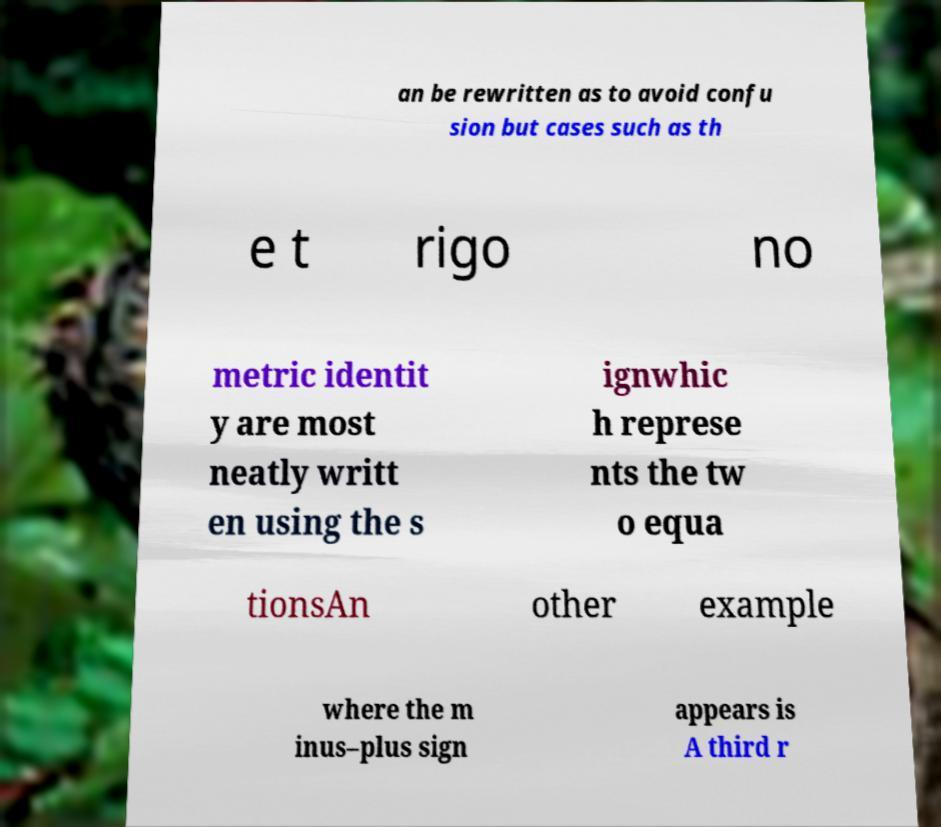I need the written content from this picture converted into text. Can you do that? an be rewritten as to avoid confu sion but cases such as th e t rigo no metric identit y are most neatly writt en using the s ignwhic h represe nts the tw o equa tionsAn other example where the m inus–plus sign appears is A third r 